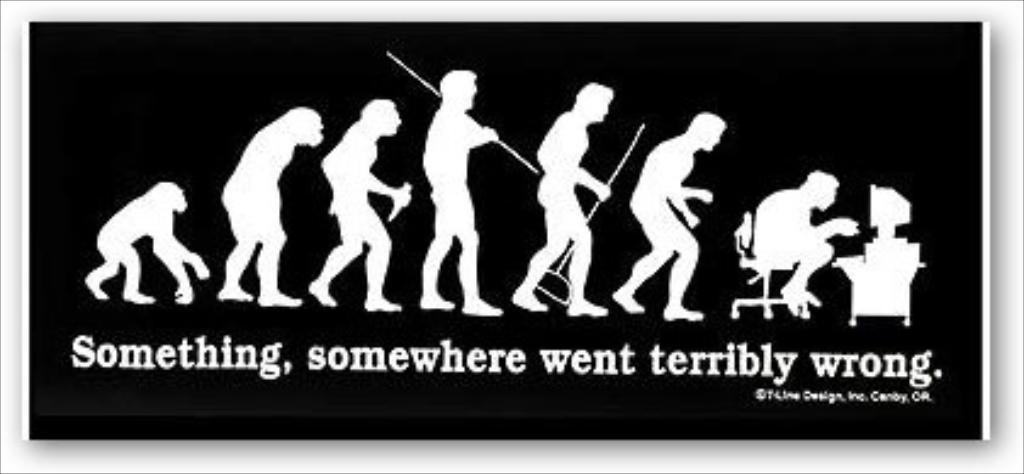<image>
Render a clear and concise summary of the photo. An evolution-themed illustration jokes that something went terribly wrong somewhere. 